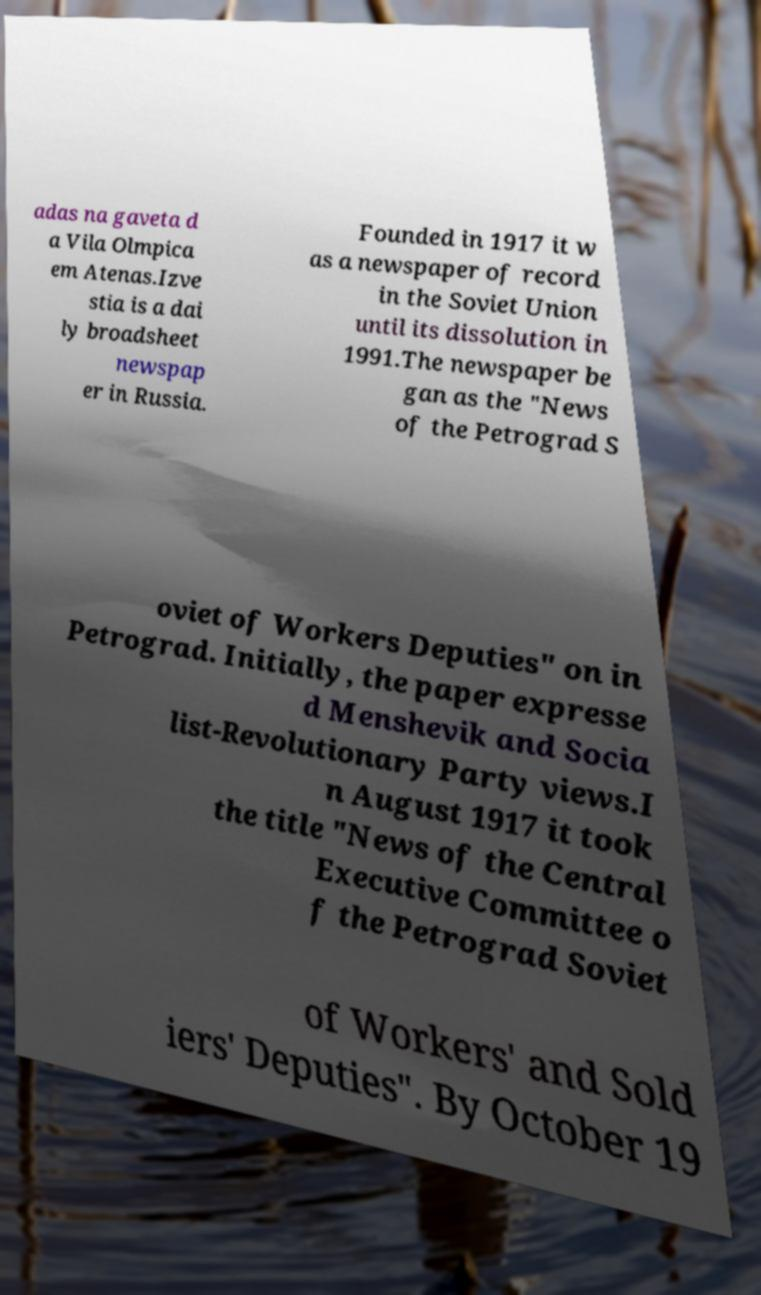Please read and relay the text visible in this image. What does it say? adas na gaveta d a Vila Olmpica em Atenas.Izve stia is a dai ly broadsheet newspap er in Russia. Founded in 1917 it w as a newspaper of record in the Soviet Union until its dissolution in 1991.The newspaper be gan as the "News of the Petrograd S oviet of Workers Deputies" on in Petrograd. Initially, the paper expresse d Menshevik and Socia list-Revolutionary Party views.I n August 1917 it took the title "News of the Central Executive Committee o f the Petrograd Soviet of Workers' and Sold iers' Deputies". By October 19 